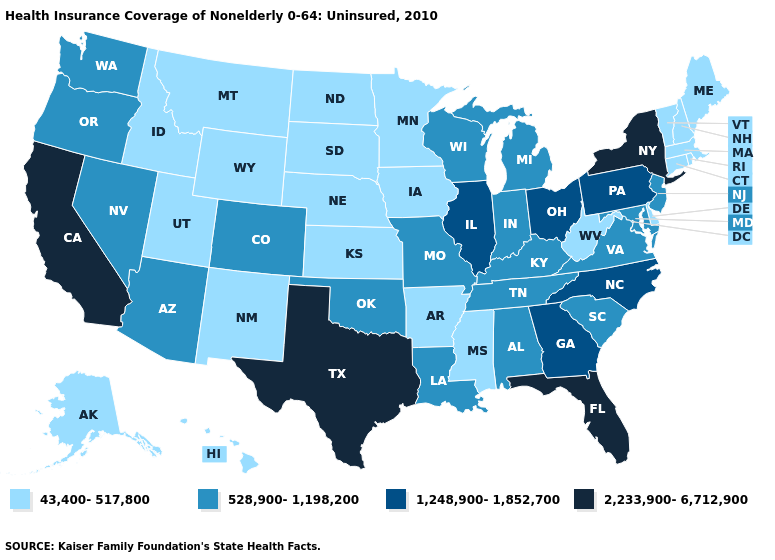What is the lowest value in states that border Nevada?
Write a very short answer. 43,400-517,800. Does New Mexico have the same value as Washington?
Concise answer only. No. What is the highest value in the USA?
Answer briefly. 2,233,900-6,712,900. Does Minnesota have the highest value in the USA?
Write a very short answer. No. Name the states that have a value in the range 1,248,900-1,852,700?
Answer briefly. Georgia, Illinois, North Carolina, Ohio, Pennsylvania. What is the highest value in the USA?
Be succinct. 2,233,900-6,712,900. Among the states that border Wisconsin , which have the lowest value?
Concise answer only. Iowa, Minnesota. What is the highest value in the USA?
Concise answer only. 2,233,900-6,712,900. Is the legend a continuous bar?
Be succinct. No. What is the highest value in the USA?
Answer briefly. 2,233,900-6,712,900. What is the value of Mississippi?
Write a very short answer. 43,400-517,800. Does Nevada have a higher value than Utah?
Be succinct. Yes. What is the value of Virginia?
Answer briefly. 528,900-1,198,200. Among the states that border Indiana , which have the lowest value?
Quick response, please. Kentucky, Michigan. Which states have the lowest value in the USA?
Concise answer only. Alaska, Arkansas, Connecticut, Delaware, Hawaii, Idaho, Iowa, Kansas, Maine, Massachusetts, Minnesota, Mississippi, Montana, Nebraska, New Hampshire, New Mexico, North Dakota, Rhode Island, South Dakota, Utah, Vermont, West Virginia, Wyoming. 